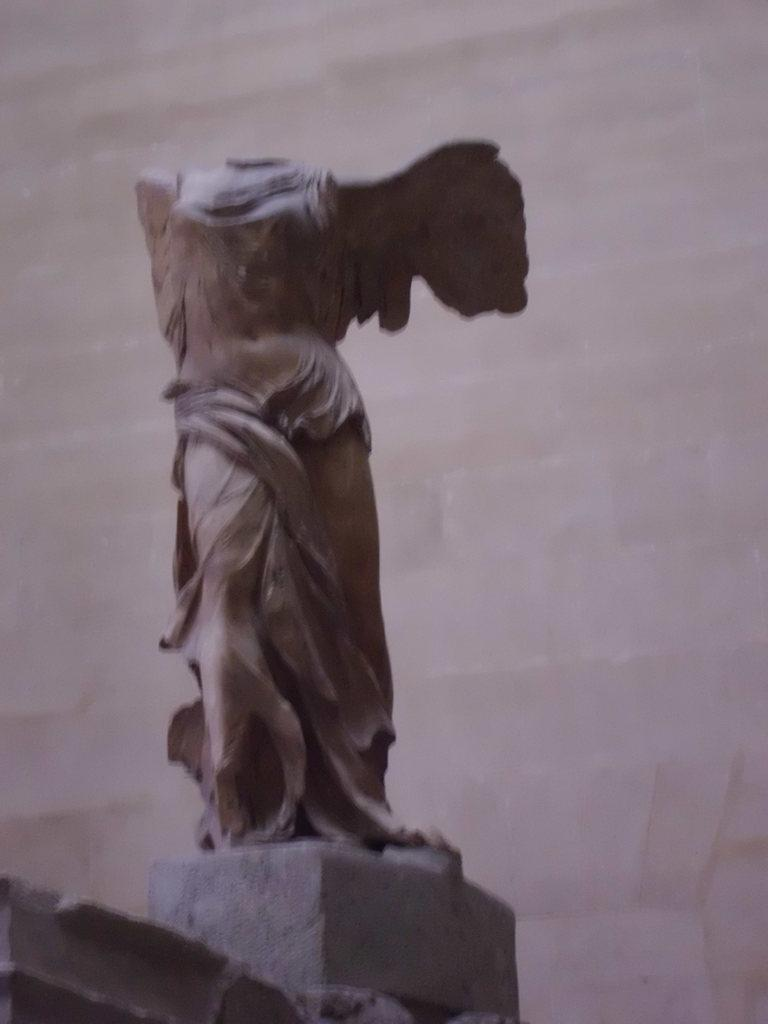What is the main subject in the center of the image? There is a statue in the center of the image. What can be seen in the background of the image? There is a wall in the background of the image. How many snakes are wrapped around the statue in the image? There are no snakes present in the image; the statue is not depicted with any snakes. 